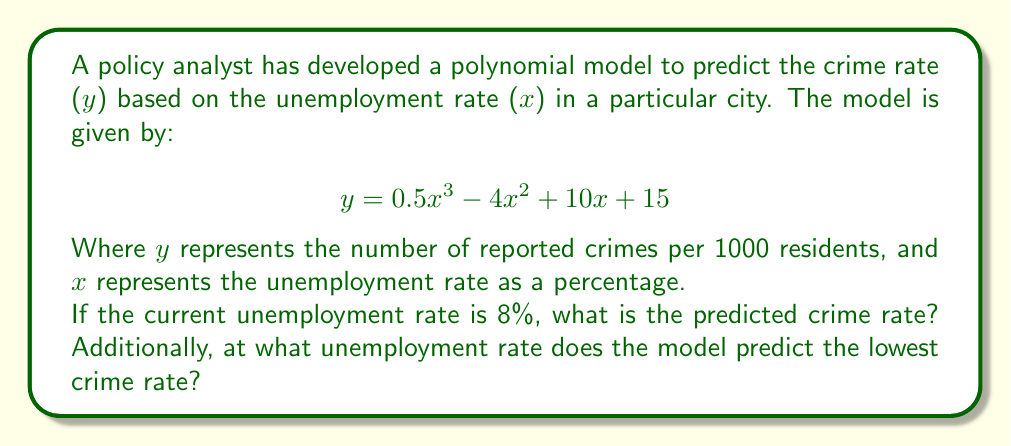Can you solve this math problem? To solve this problem, we'll follow these steps:

1. Calculate the predicted crime rate at 8% unemployment:
   Substitute x = 8 into the given polynomial function:
   $$y = 0.5(8)^3 - 4(8)^2 + 10(8) + 15$$
   $$y = 0.5(512) - 4(64) + 80 + 15$$
   $$y = 256 - 256 + 80 + 15$$
   $$y = 95$$

2. To find the unemployment rate that predicts the lowest crime rate, we need to find the minimum point of the function:
   a) First, find the derivative of the function:
      $$y' = 1.5x^2 - 8x + 10$$
   
   b) Set the derivative equal to zero and solve for x:
      $$1.5x^2 - 8x + 10 = 0$$
      This is a quadratic equation. We can solve it using the quadratic formula:
      $$x = \frac{-b \pm \sqrt{b^2 - 4ac}}{2a}$$
      Where a = 1.5, b = -8, and c = 10
   
   c) Plugging in these values:
      $$x = \frac{8 \pm \sqrt{64 - 60}}{3} = \frac{8 \pm 2}{3}$$
   
   d) This gives us two solutions:
      $$x_1 = \frac{8 + 2}{3} = \frac{10}{3} \approx 3.33$$
      $$x_2 = \frac{8 - 2}{3} = 2$$
   
   e) To determine which of these is the minimum (rather than maximum), we can check the second derivative:
      $$y'' = 3x - 8$$
      At x = 2, y'' = -2 (negative, so this is a maximum)
      At x = 3.33, y'' = 2 (positive, so this is a minimum)

Therefore, the model predicts the lowest crime rate at an unemployment rate of approximately 3.33%.
Answer: 95 crimes per 1000 residents at 8% unemployment; lowest crime rate at 3.33% unemployment 